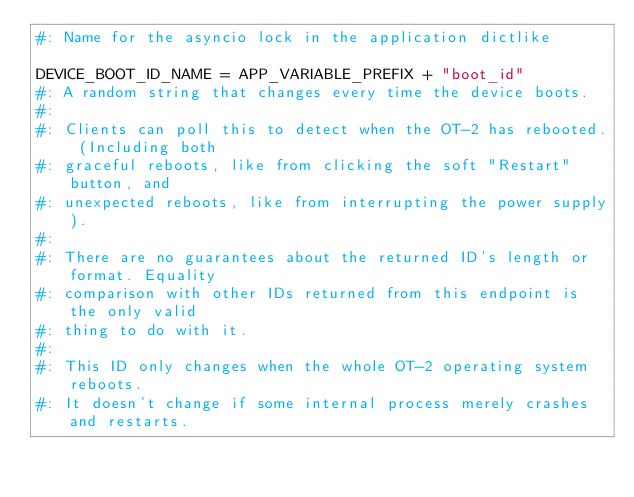Convert code to text. <code><loc_0><loc_0><loc_500><loc_500><_Python_>#: Name for the asyncio lock in the application dictlike

DEVICE_BOOT_ID_NAME = APP_VARIABLE_PREFIX + "boot_id"
#: A random string that changes every time the device boots.
#:
#: Clients can poll this to detect when the OT-2 has rebooted. (Including both
#: graceful reboots, like from clicking the soft "Restart" button, and
#: unexpected reboots, like from interrupting the power supply).
#:
#: There are no guarantees about the returned ID's length or format. Equality
#: comparison with other IDs returned from this endpoint is the only valid
#: thing to do with it.
#:
#: This ID only changes when the whole OT-2 operating system reboots.
#: It doesn't change if some internal process merely crashes and restarts.
</code> 